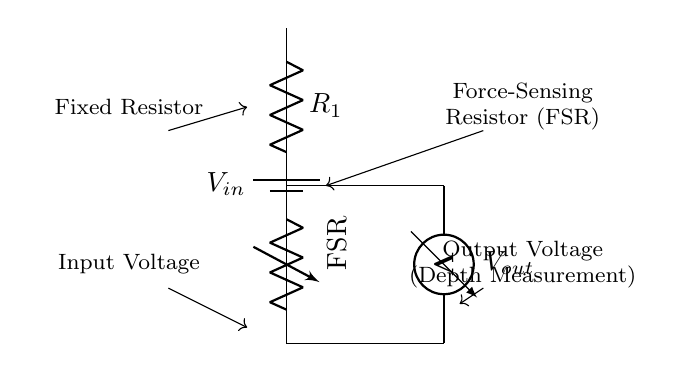What component is used to sense force in this circuit? The circuit diagram labels a component as "FSR," which stands for Force-Sensing Resistor, indicating that this is the component used for sensing force.
Answer: Force-Sensing Resistor What does the output voltage represent? The label on the circuit diagram indicates that the output voltage, noted as "V out," corresponds to the depth measurement, which is what the circuit is designed to measure.
Answer: Depth Measurement Which component is fixed in the voltage divider? The circuit indicates a component labeled simply as "R1," which is a fixed resistor, meaning it has a constant resistance value.
Answer: Fixed Resistor How does the output voltage change with increasing force applied? In a voltage divider with increasing resistance from the FSR due to increased force, the voltage across the FSR increases, resulting in a higher output voltage since it divides the input voltage according to the resistances.
Answer: Increases If the input voltage is four volts, what will happen to the output voltage when the resistance of the FSR decreases? As the resistance of the FSR decreases, according to the voltage divider formula, the output voltage will decrease because more voltage is developed across the fixed resistor R1 when the total resistance is lowered.
Answer: Decreases In terms of operation, how does this voltage divider measure depth? The voltage divider operates by varying the resistance of the Force-Sensing Resistor in response to hydrostatic pressure at varying depths, thus changing the output voltage. The output voltage reflects the depth based on the resistance changes as water pressure increases with depth.
Answer: By varying resistance 